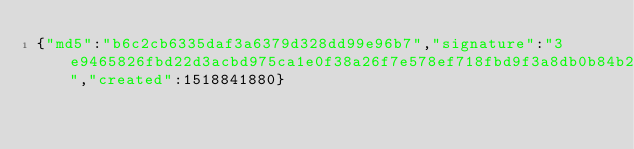Convert code to text. <code><loc_0><loc_0><loc_500><loc_500><_SML_>{"md5":"b6c2cb6335daf3a6379d328dd99e96b7","signature":"3e9465826fbd22d3acbd975ca1e0f38a26f7e578ef718fbd9f3a8db0b84b207e8fdf551394b2c345acfaa2b2d287bb30a6e1551b1472f9b4c8f087ec3161a302","created":1518841880}</code> 